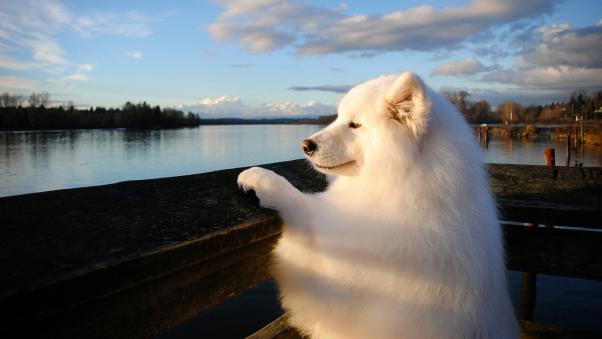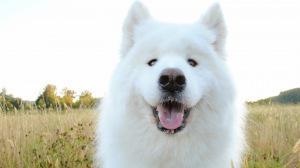The first image is the image on the left, the second image is the image on the right. Assess this claim about the two images: "The right image contains a white dog facing towards the right.". Correct or not? Answer yes or no. No. 